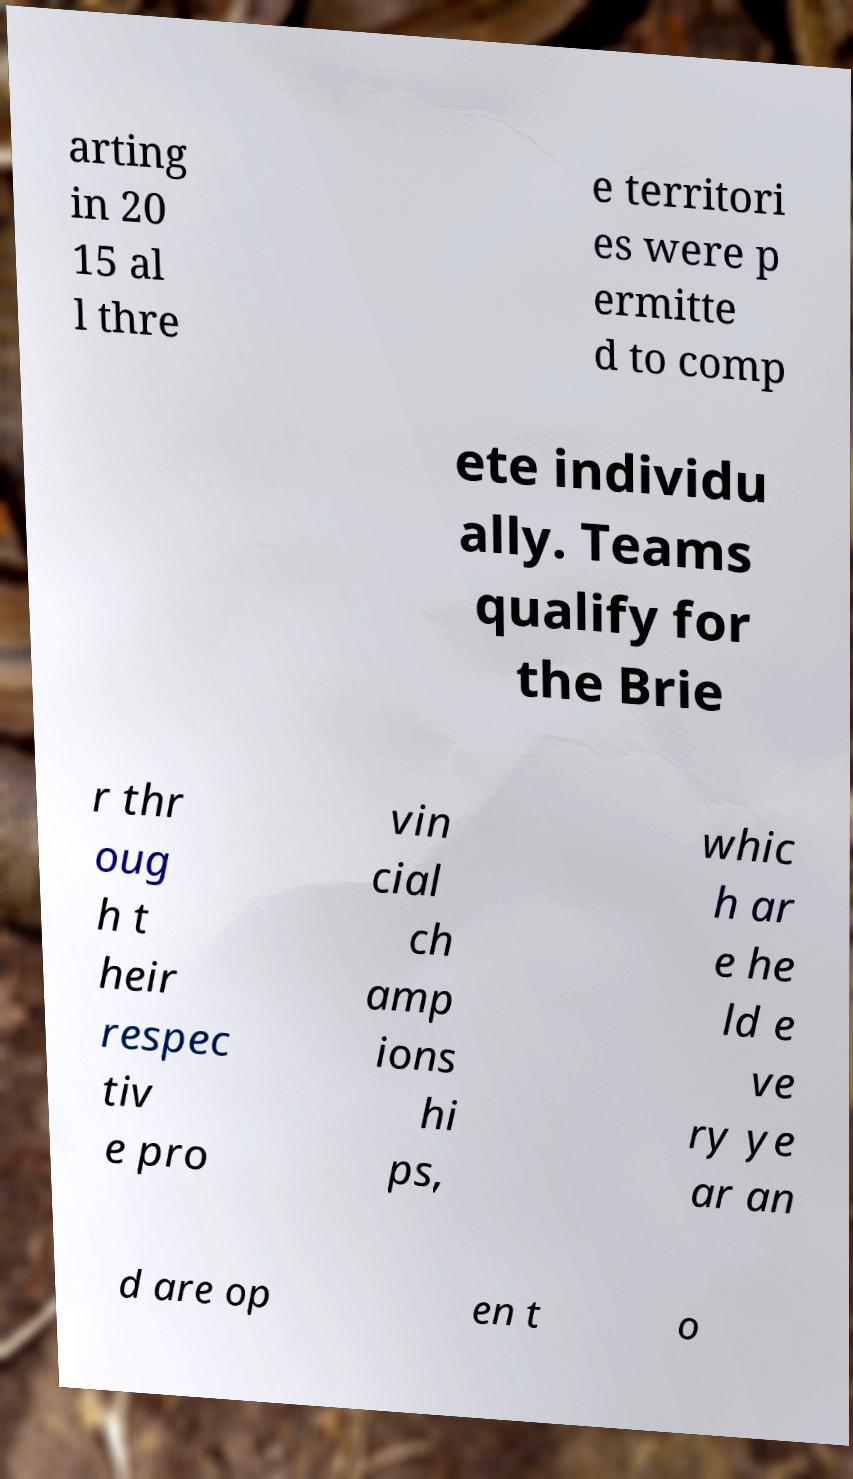Could you assist in decoding the text presented in this image and type it out clearly? arting in 20 15 al l thre e territori es were p ermitte d to comp ete individu ally. Teams qualify for the Brie r thr oug h t heir respec tiv e pro vin cial ch amp ions hi ps, whic h ar e he ld e ve ry ye ar an d are op en t o 